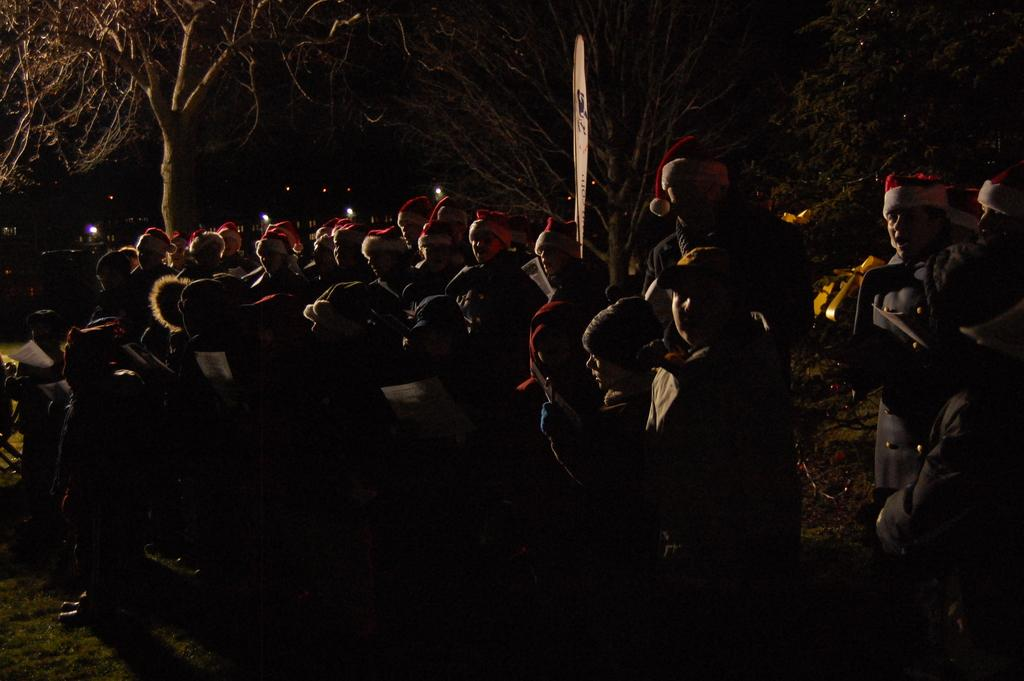What can be seen on the ground in the image? There are people on the ground in the image. What is visible in the background of the image? There are trees and lights in the background of the image. What type of news can be heard coming from the space station in the image? There is no space station or news present in the image; it features people on the ground and trees and lights in the background. 